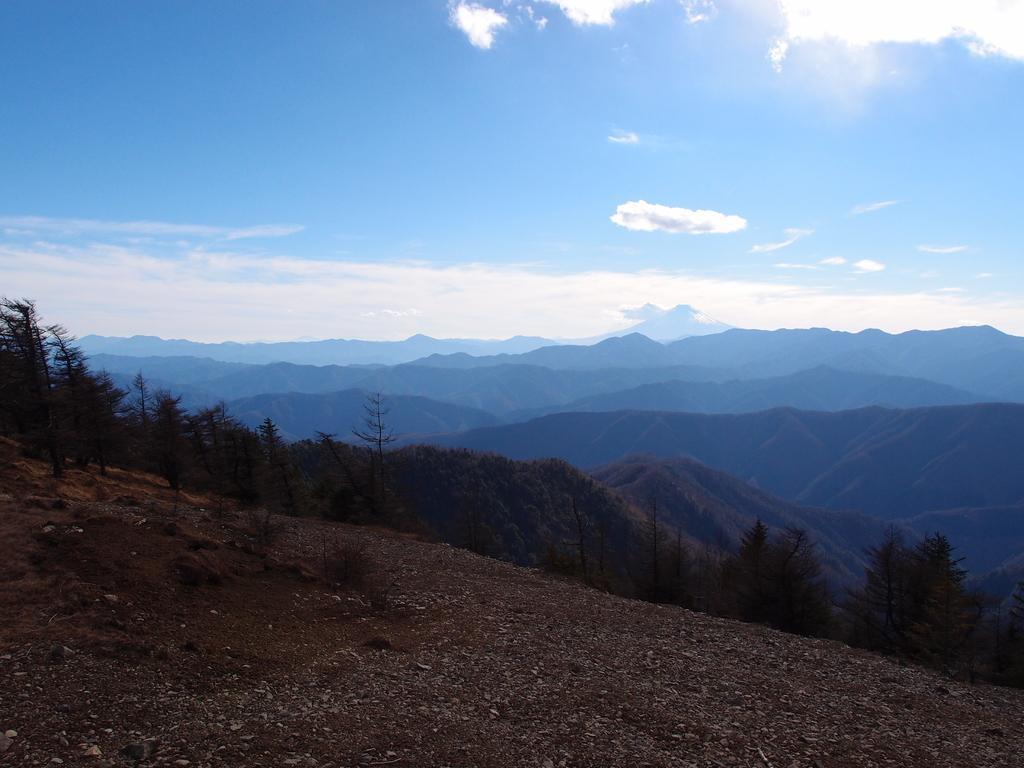Describe this image in one or two sentences. This image consists of trees in the middle, mountains in the middle, sky at the top. 